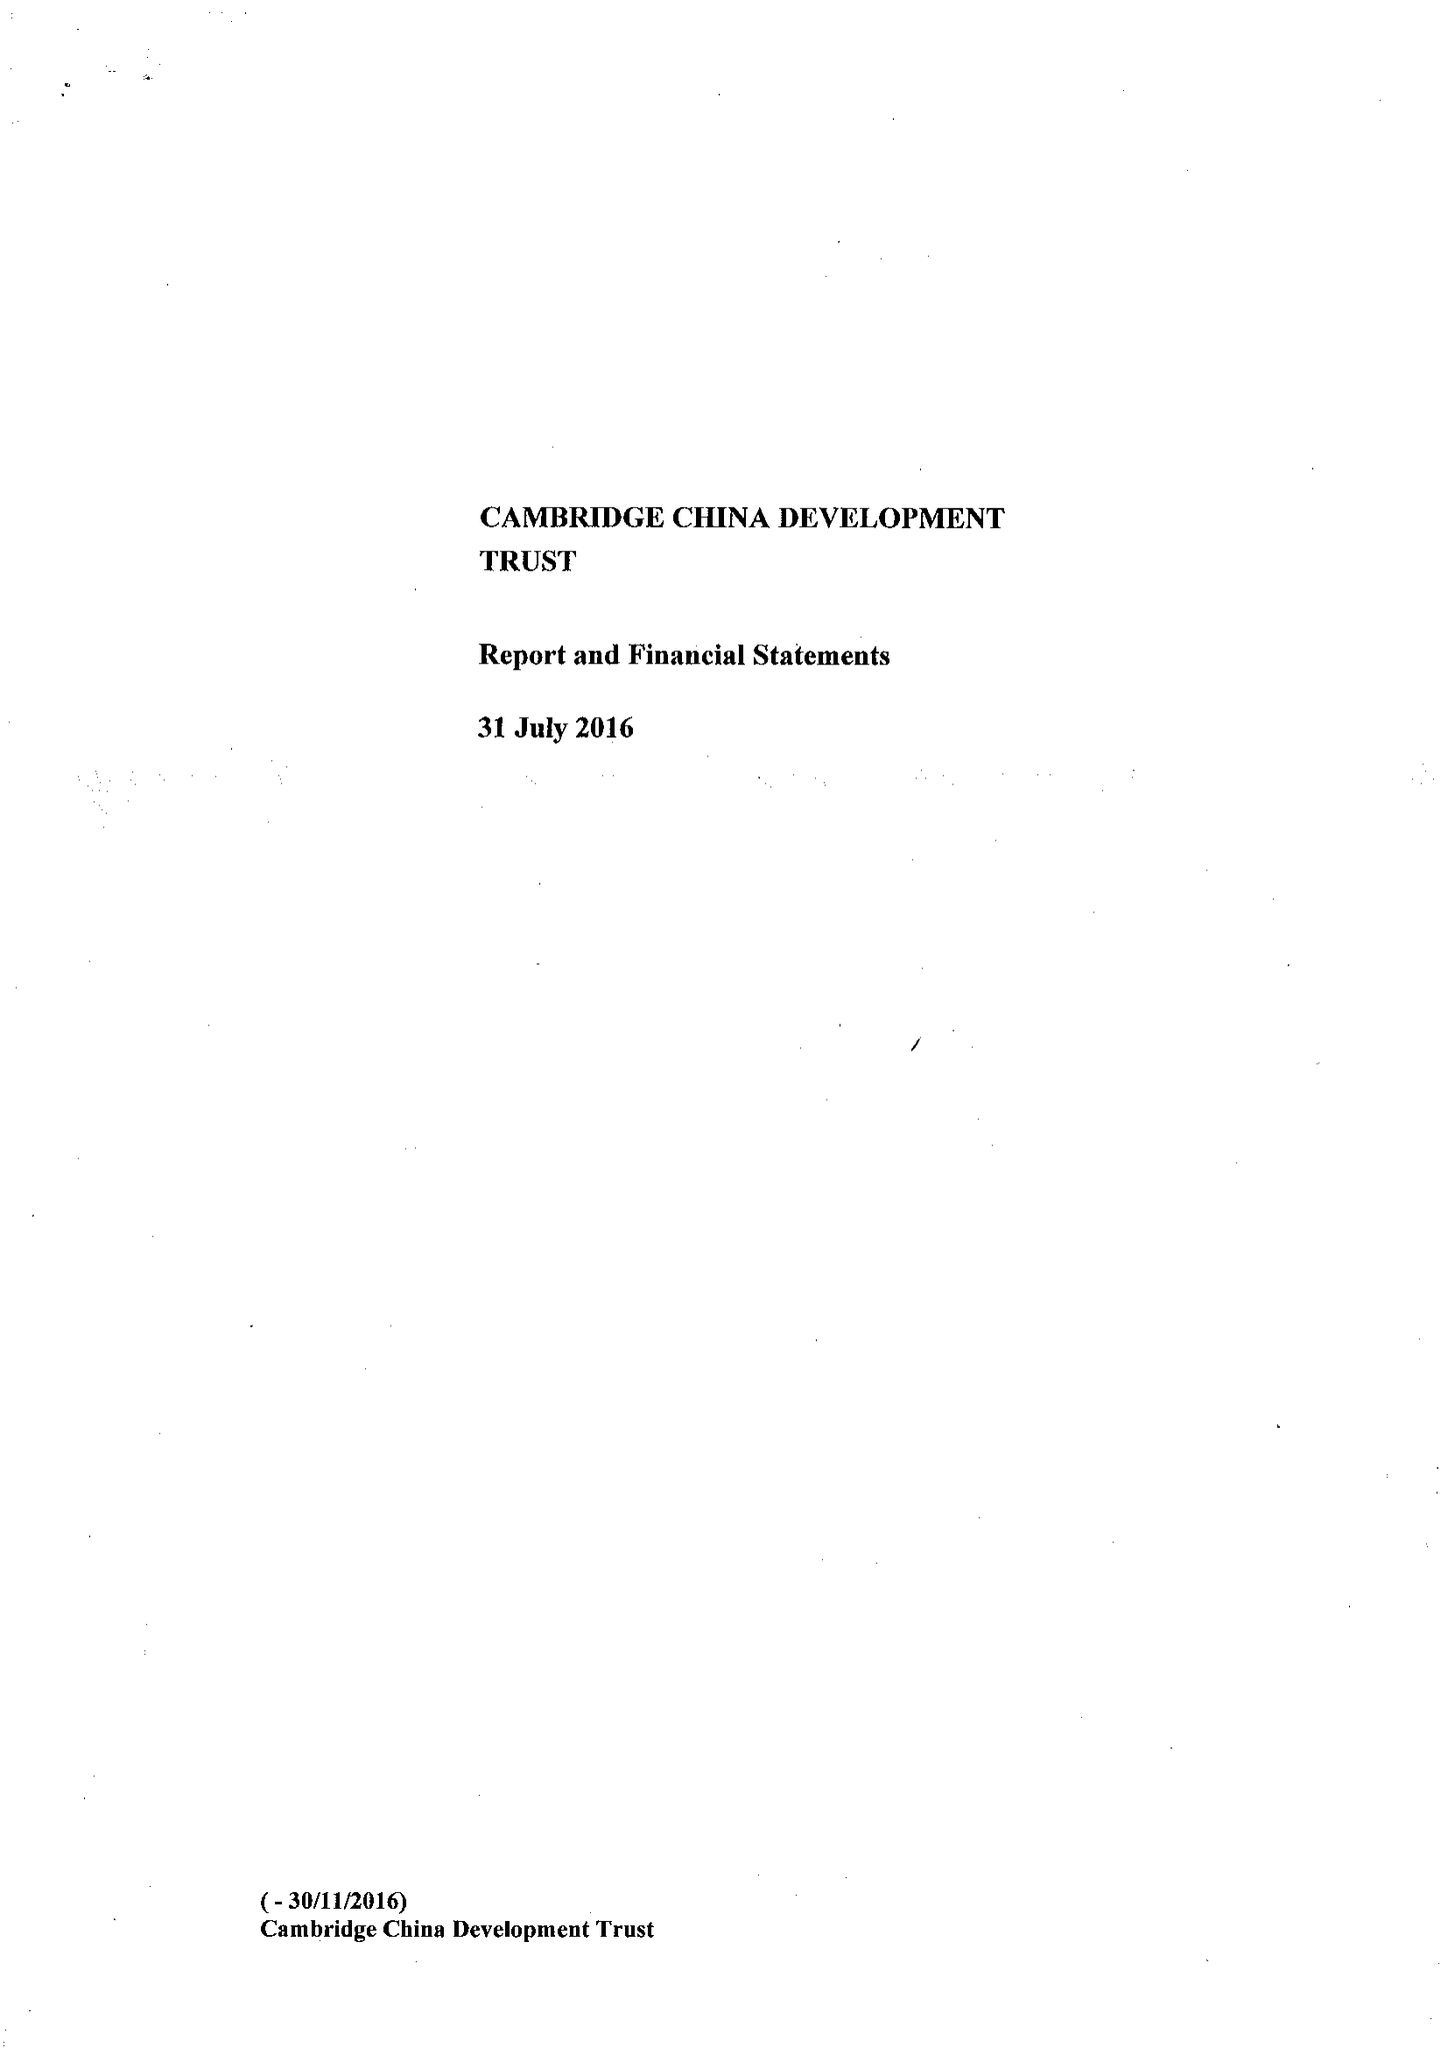What is the value for the charity_number?
Answer the question using a single word or phrase. 1111605 